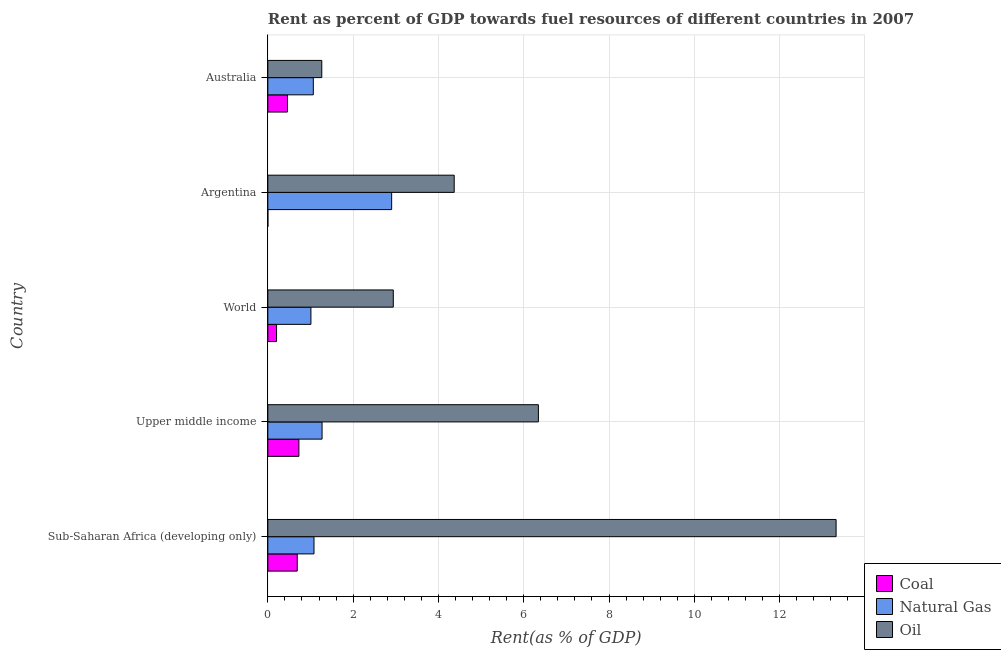How many groups of bars are there?
Your answer should be compact. 5. Are the number of bars per tick equal to the number of legend labels?
Your response must be concise. Yes. How many bars are there on the 3rd tick from the top?
Your response must be concise. 3. What is the label of the 3rd group of bars from the top?
Your response must be concise. World. What is the rent towards natural gas in Argentina?
Make the answer very short. 2.9. Across all countries, what is the maximum rent towards coal?
Offer a very short reply. 0.73. Across all countries, what is the minimum rent towards coal?
Your answer should be very brief. 0. In which country was the rent towards oil maximum?
Offer a very short reply. Sub-Saharan Africa (developing only). What is the total rent towards coal in the graph?
Your response must be concise. 2.08. What is the difference between the rent towards coal in Upper middle income and that in World?
Give a very brief answer. 0.52. What is the difference between the rent towards oil in Sub-Saharan Africa (developing only) and the rent towards coal in Upper middle income?
Make the answer very short. 12.6. What is the average rent towards natural gas per country?
Your answer should be compact. 1.47. What is the difference between the rent towards coal and rent towards oil in Upper middle income?
Offer a terse response. -5.62. In how many countries, is the rent towards oil greater than 0.4 %?
Provide a short and direct response. 5. What is the ratio of the rent towards natural gas in Argentina to that in Australia?
Provide a succinct answer. 2.72. Is the rent towards natural gas in Australia less than that in Sub-Saharan Africa (developing only)?
Your answer should be very brief. Yes. What is the difference between the highest and the second highest rent towards natural gas?
Provide a short and direct response. 1.63. What is the difference between the highest and the lowest rent towards oil?
Provide a short and direct response. 12.06. What does the 2nd bar from the top in World represents?
Keep it short and to the point. Natural Gas. What does the 2nd bar from the bottom in World represents?
Keep it short and to the point. Natural Gas. Is it the case that in every country, the sum of the rent towards coal and rent towards natural gas is greater than the rent towards oil?
Keep it short and to the point. No. How many bars are there?
Provide a short and direct response. 15. How many countries are there in the graph?
Ensure brevity in your answer.  5. Does the graph contain grids?
Provide a short and direct response. Yes. Where does the legend appear in the graph?
Your answer should be compact. Bottom right. What is the title of the graph?
Provide a short and direct response. Rent as percent of GDP towards fuel resources of different countries in 2007. Does "Travel services" appear as one of the legend labels in the graph?
Your answer should be compact. No. What is the label or title of the X-axis?
Offer a very short reply. Rent(as % of GDP). What is the Rent(as % of GDP) of Coal in Sub-Saharan Africa (developing only)?
Offer a terse response. 0.69. What is the Rent(as % of GDP) of Natural Gas in Sub-Saharan Africa (developing only)?
Give a very brief answer. 1.08. What is the Rent(as % of GDP) in Oil in Sub-Saharan Africa (developing only)?
Provide a succinct answer. 13.33. What is the Rent(as % of GDP) of Coal in Upper middle income?
Your answer should be compact. 0.73. What is the Rent(as % of GDP) of Natural Gas in Upper middle income?
Your answer should be very brief. 1.27. What is the Rent(as % of GDP) of Oil in Upper middle income?
Keep it short and to the point. 6.34. What is the Rent(as % of GDP) of Coal in World?
Your response must be concise. 0.2. What is the Rent(as % of GDP) of Natural Gas in World?
Give a very brief answer. 1.01. What is the Rent(as % of GDP) in Oil in World?
Provide a short and direct response. 2.94. What is the Rent(as % of GDP) in Coal in Argentina?
Give a very brief answer. 0. What is the Rent(as % of GDP) in Natural Gas in Argentina?
Provide a short and direct response. 2.9. What is the Rent(as % of GDP) of Oil in Argentina?
Keep it short and to the point. 4.37. What is the Rent(as % of GDP) in Coal in Australia?
Offer a terse response. 0.46. What is the Rent(as % of GDP) in Natural Gas in Australia?
Your answer should be very brief. 1.07. What is the Rent(as % of GDP) in Oil in Australia?
Make the answer very short. 1.26. Across all countries, what is the maximum Rent(as % of GDP) in Coal?
Offer a very short reply. 0.73. Across all countries, what is the maximum Rent(as % of GDP) in Natural Gas?
Your response must be concise. 2.9. Across all countries, what is the maximum Rent(as % of GDP) of Oil?
Ensure brevity in your answer.  13.33. Across all countries, what is the minimum Rent(as % of GDP) of Coal?
Provide a short and direct response. 0. Across all countries, what is the minimum Rent(as % of GDP) in Natural Gas?
Ensure brevity in your answer.  1.01. Across all countries, what is the minimum Rent(as % of GDP) in Oil?
Make the answer very short. 1.26. What is the total Rent(as % of GDP) in Coal in the graph?
Offer a very short reply. 2.08. What is the total Rent(as % of GDP) in Natural Gas in the graph?
Make the answer very short. 7.33. What is the total Rent(as % of GDP) in Oil in the graph?
Keep it short and to the point. 28.25. What is the difference between the Rent(as % of GDP) of Coal in Sub-Saharan Africa (developing only) and that in Upper middle income?
Offer a terse response. -0.04. What is the difference between the Rent(as % of GDP) in Natural Gas in Sub-Saharan Africa (developing only) and that in Upper middle income?
Keep it short and to the point. -0.19. What is the difference between the Rent(as % of GDP) in Oil in Sub-Saharan Africa (developing only) and that in Upper middle income?
Your answer should be compact. 6.98. What is the difference between the Rent(as % of GDP) in Coal in Sub-Saharan Africa (developing only) and that in World?
Keep it short and to the point. 0.48. What is the difference between the Rent(as % of GDP) in Natural Gas in Sub-Saharan Africa (developing only) and that in World?
Ensure brevity in your answer.  0.07. What is the difference between the Rent(as % of GDP) in Oil in Sub-Saharan Africa (developing only) and that in World?
Your response must be concise. 10.38. What is the difference between the Rent(as % of GDP) of Coal in Sub-Saharan Africa (developing only) and that in Argentina?
Ensure brevity in your answer.  0.69. What is the difference between the Rent(as % of GDP) in Natural Gas in Sub-Saharan Africa (developing only) and that in Argentina?
Offer a terse response. -1.82. What is the difference between the Rent(as % of GDP) of Oil in Sub-Saharan Africa (developing only) and that in Argentina?
Provide a succinct answer. 8.96. What is the difference between the Rent(as % of GDP) of Coal in Sub-Saharan Africa (developing only) and that in Australia?
Your answer should be very brief. 0.23. What is the difference between the Rent(as % of GDP) of Natural Gas in Sub-Saharan Africa (developing only) and that in Australia?
Make the answer very short. 0.02. What is the difference between the Rent(as % of GDP) in Oil in Sub-Saharan Africa (developing only) and that in Australia?
Offer a very short reply. 12.06. What is the difference between the Rent(as % of GDP) of Coal in Upper middle income and that in World?
Ensure brevity in your answer.  0.52. What is the difference between the Rent(as % of GDP) in Natural Gas in Upper middle income and that in World?
Keep it short and to the point. 0.26. What is the difference between the Rent(as % of GDP) of Oil in Upper middle income and that in World?
Provide a succinct answer. 3.4. What is the difference between the Rent(as % of GDP) of Coal in Upper middle income and that in Argentina?
Your response must be concise. 0.73. What is the difference between the Rent(as % of GDP) of Natural Gas in Upper middle income and that in Argentina?
Ensure brevity in your answer.  -1.63. What is the difference between the Rent(as % of GDP) in Oil in Upper middle income and that in Argentina?
Ensure brevity in your answer.  1.97. What is the difference between the Rent(as % of GDP) of Coal in Upper middle income and that in Australia?
Ensure brevity in your answer.  0.27. What is the difference between the Rent(as % of GDP) of Natural Gas in Upper middle income and that in Australia?
Make the answer very short. 0.21. What is the difference between the Rent(as % of GDP) of Oil in Upper middle income and that in Australia?
Make the answer very short. 5.08. What is the difference between the Rent(as % of GDP) of Coal in World and that in Argentina?
Offer a terse response. 0.2. What is the difference between the Rent(as % of GDP) in Natural Gas in World and that in Argentina?
Provide a succinct answer. -1.89. What is the difference between the Rent(as % of GDP) of Oil in World and that in Argentina?
Your answer should be very brief. -1.43. What is the difference between the Rent(as % of GDP) of Coal in World and that in Australia?
Make the answer very short. -0.26. What is the difference between the Rent(as % of GDP) in Natural Gas in World and that in Australia?
Offer a terse response. -0.06. What is the difference between the Rent(as % of GDP) of Oil in World and that in Australia?
Offer a very short reply. 1.68. What is the difference between the Rent(as % of GDP) of Coal in Argentina and that in Australia?
Offer a very short reply. -0.46. What is the difference between the Rent(as % of GDP) of Natural Gas in Argentina and that in Australia?
Provide a succinct answer. 1.84. What is the difference between the Rent(as % of GDP) of Oil in Argentina and that in Australia?
Your answer should be very brief. 3.11. What is the difference between the Rent(as % of GDP) in Coal in Sub-Saharan Africa (developing only) and the Rent(as % of GDP) in Natural Gas in Upper middle income?
Provide a succinct answer. -0.58. What is the difference between the Rent(as % of GDP) of Coal in Sub-Saharan Africa (developing only) and the Rent(as % of GDP) of Oil in Upper middle income?
Your answer should be very brief. -5.66. What is the difference between the Rent(as % of GDP) in Natural Gas in Sub-Saharan Africa (developing only) and the Rent(as % of GDP) in Oil in Upper middle income?
Your response must be concise. -5.26. What is the difference between the Rent(as % of GDP) in Coal in Sub-Saharan Africa (developing only) and the Rent(as % of GDP) in Natural Gas in World?
Offer a terse response. -0.32. What is the difference between the Rent(as % of GDP) of Coal in Sub-Saharan Africa (developing only) and the Rent(as % of GDP) of Oil in World?
Ensure brevity in your answer.  -2.25. What is the difference between the Rent(as % of GDP) in Natural Gas in Sub-Saharan Africa (developing only) and the Rent(as % of GDP) in Oil in World?
Give a very brief answer. -1.86. What is the difference between the Rent(as % of GDP) in Coal in Sub-Saharan Africa (developing only) and the Rent(as % of GDP) in Natural Gas in Argentina?
Your response must be concise. -2.21. What is the difference between the Rent(as % of GDP) in Coal in Sub-Saharan Africa (developing only) and the Rent(as % of GDP) in Oil in Argentina?
Give a very brief answer. -3.68. What is the difference between the Rent(as % of GDP) in Natural Gas in Sub-Saharan Africa (developing only) and the Rent(as % of GDP) in Oil in Argentina?
Your response must be concise. -3.29. What is the difference between the Rent(as % of GDP) of Coal in Sub-Saharan Africa (developing only) and the Rent(as % of GDP) of Natural Gas in Australia?
Give a very brief answer. -0.38. What is the difference between the Rent(as % of GDP) of Coal in Sub-Saharan Africa (developing only) and the Rent(as % of GDP) of Oil in Australia?
Ensure brevity in your answer.  -0.58. What is the difference between the Rent(as % of GDP) in Natural Gas in Sub-Saharan Africa (developing only) and the Rent(as % of GDP) in Oil in Australia?
Provide a succinct answer. -0.18. What is the difference between the Rent(as % of GDP) in Coal in Upper middle income and the Rent(as % of GDP) in Natural Gas in World?
Your response must be concise. -0.28. What is the difference between the Rent(as % of GDP) in Coal in Upper middle income and the Rent(as % of GDP) in Oil in World?
Keep it short and to the point. -2.21. What is the difference between the Rent(as % of GDP) of Natural Gas in Upper middle income and the Rent(as % of GDP) of Oil in World?
Your answer should be very brief. -1.67. What is the difference between the Rent(as % of GDP) in Coal in Upper middle income and the Rent(as % of GDP) in Natural Gas in Argentina?
Keep it short and to the point. -2.17. What is the difference between the Rent(as % of GDP) in Coal in Upper middle income and the Rent(as % of GDP) in Oil in Argentina?
Your response must be concise. -3.64. What is the difference between the Rent(as % of GDP) in Natural Gas in Upper middle income and the Rent(as % of GDP) in Oil in Argentina?
Provide a succinct answer. -3.1. What is the difference between the Rent(as % of GDP) of Coal in Upper middle income and the Rent(as % of GDP) of Natural Gas in Australia?
Provide a short and direct response. -0.34. What is the difference between the Rent(as % of GDP) of Coal in Upper middle income and the Rent(as % of GDP) of Oil in Australia?
Your answer should be very brief. -0.54. What is the difference between the Rent(as % of GDP) of Natural Gas in Upper middle income and the Rent(as % of GDP) of Oil in Australia?
Keep it short and to the point. 0.01. What is the difference between the Rent(as % of GDP) of Coal in World and the Rent(as % of GDP) of Natural Gas in Argentina?
Keep it short and to the point. -2.7. What is the difference between the Rent(as % of GDP) of Coal in World and the Rent(as % of GDP) of Oil in Argentina?
Offer a very short reply. -4.17. What is the difference between the Rent(as % of GDP) of Natural Gas in World and the Rent(as % of GDP) of Oil in Argentina?
Provide a short and direct response. -3.36. What is the difference between the Rent(as % of GDP) in Coal in World and the Rent(as % of GDP) in Natural Gas in Australia?
Ensure brevity in your answer.  -0.86. What is the difference between the Rent(as % of GDP) in Coal in World and the Rent(as % of GDP) in Oil in Australia?
Give a very brief answer. -1.06. What is the difference between the Rent(as % of GDP) of Natural Gas in World and the Rent(as % of GDP) of Oil in Australia?
Offer a very short reply. -0.25. What is the difference between the Rent(as % of GDP) of Coal in Argentina and the Rent(as % of GDP) of Natural Gas in Australia?
Provide a short and direct response. -1.07. What is the difference between the Rent(as % of GDP) in Coal in Argentina and the Rent(as % of GDP) in Oil in Australia?
Provide a short and direct response. -1.26. What is the difference between the Rent(as % of GDP) of Natural Gas in Argentina and the Rent(as % of GDP) of Oil in Australia?
Make the answer very short. 1.64. What is the average Rent(as % of GDP) of Coal per country?
Provide a succinct answer. 0.42. What is the average Rent(as % of GDP) in Natural Gas per country?
Provide a short and direct response. 1.47. What is the average Rent(as % of GDP) of Oil per country?
Provide a succinct answer. 5.65. What is the difference between the Rent(as % of GDP) of Coal and Rent(as % of GDP) of Natural Gas in Sub-Saharan Africa (developing only)?
Provide a succinct answer. -0.39. What is the difference between the Rent(as % of GDP) in Coal and Rent(as % of GDP) in Oil in Sub-Saharan Africa (developing only)?
Make the answer very short. -12.64. What is the difference between the Rent(as % of GDP) in Natural Gas and Rent(as % of GDP) in Oil in Sub-Saharan Africa (developing only)?
Your response must be concise. -12.24. What is the difference between the Rent(as % of GDP) in Coal and Rent(as % of GDP) in Natural Gas in Upper middle income?
Your answer should be very brief. -0.54. What is the difference between the Rent(as % of GDP) of Coal and Rent(as % of GDP) of Oil in Upper middle income?
Ensure brevity in your answer.  -5.62. What is the difference between the Rent(as % of GDP) in Natural Gas and Rent(as % of GDP) in Oil in Upper middle income?
Your response must be concise. -5.07. What is the difference between the Rent(as % of GDP) in Coal and Rent(as % of GDP) in Natural Gas in World?
Offer a terse response. -0.81. What is the difference between the Rent(as % of GDP) of Coal and Rent(as % of GDP) of Oil in World?
Provide a short and direct response. -2.74. What is the difference between the Rent(as % of GDP) of Natural Gas and Rent(as % of GDP) of Oil in World?
Offer a very short reply. -1.93. What is the difference between the Rent(as % of GDP) of Coal and Rent(as % of GDP) of Natural Gas in Argentina?
Provide a short and direct response. -2.9. What is the difference between the Rent(as % of GDP) of Coal and Rent(as % of GDP) of Oil in Argentina?
Offer a terse response. -4.37. What is the difference between the Rent(as % of GDP) of Natural Gas and Rent(as % of GDP) of Oil in Argentina?
Provide a succinct answer. -1.47. What is the difference between the Rent(as % of GDP) in Coal and Rent(as % of GDP) in Natural Gas in Australia?
Make the answer very short. -0.61. What is the difference between the Rent(as % of GDP) of Coal and Rent(as % of GDP) of Oil in Australia?
Your response must be concise. -0.81. What is the difference between the Rent(as % of GDP) in Natural Gas and Rent(as % of GDP) in Oil in Australia?
Your answer should be very brief. -0.2. What is the ratio of the Rent(as % of GDP) of Coal in Sub-Saharan Africa (developing only) to that in Upper middle income?
Provide a short and direct response. 0.95. What is the ratio of the Rent(as % of GDP) in Natural Gas in Sub-Saharan Africa (developing only) to that in Upper middle income?
Give a very brief answer. 0.85. What is the ratio of the Rent(as % of GDP) in Oil in Sub-Saharan Africa (developing only) to that in Upper middle income?
Provide a short and direct response. 2.1. What is the ratio of the Rent(as % of GDP) in Coal in Sub-Saharan Africa (developing only) to that in World?
Offer a terse response. 3.37. What is the ratio of the Rent(as % of GDP) of Natural Gas in Sub-Saharan Africa (developing only) to that in World?
Keep it short and to the point. 1.07. What is the ratio of the Rent(as % of GDP) of Oil in Sub-Saharan Africa (developing only) to that in World?
Keep it short and to the point. 4.53. What is the ratio of the Rent(as % of GDP) in Coal in Sub-Saharan Africa (developing only) to that in Argentina?
Your answer should be compact. 1523.21. What is the ratio of the Rent(as % of GDP) in Natural Gas in Sub-Saharan Africa (developing only) to that in Argentina?
Offer a very short reply. 0.37. What is the ratio of the Rent(as % of GDP) of Oil in Sub-Saharan Africa (developing only) to that in Argentina?
Provide a succinct answer. 3.05. What is the ratio of the Rent(as % of GDP) of Coal in Sub-Saharan Africa (developing only) to that in Australia?
Provide a succinct answer. 1.5. What is the ratio of the Rent(as % of GDP) in Natural Gas in Sub-Saharan Africa (developing only) to that in Australia?
Your answer should be very brief. 1.01. What is the ratio of the Rent(as % of GDP) in Oil in Sub-Saharan Africa (developing only) to that in Australia?
Ensure brevity in your answer.  10.54. What is the ratio of the Rent(as % of GDP) of Coal in Upper middle income to that in World?
Your response must be concise. 3.56. What is the ratio of the Rent(as % of GDP) of Natural Gas in Upper middle income to that in World?
Ensure brevity in your answer.  1.26. What is the ratio of the Rent(as % of GDP) in Oil in Upper middle income to that in World?
Provide a short and direct response. 2.16. What is the ratio of the Rent(as % of GDP) in Coal in Upper middle income to that in Argentina?
Your answer should be compact. 1610.21. What is the ratio of the Rent(as % of GDP) in Natural Gas in Upper middle income to that in Argentina?
Your answer should be very brief. 0.44. What is the ratio of the Rent(as % of GDP) of Oil in Upper middle income to that in Argentina?
Provide a succinct answer. 1.45. What is the ratio of the Rent(as % of GDP) in Coal in Upper middle income to that in Australia?
Provide a succinct answer. 1.58. What is the ratio of the Rent(as % of GDP) of Natural Gas in Upper middle income to that in Australia?
Your answer should be very brief. 1.19. What is the ratio of the Rent(as % of GDP) in Oil in Upper middle income to that in Australia?
Give a very brief answer. 5.02. What is the ratio of the Rent(as % of GDP) in Coal in World to that in Argentina?
Your answer should be very brief. 451.77. What is the ratio of the Rent(as % of GDP) in Natural Gas in World to that in Argentina?
Your answer should be very brief. 0.35. What is the ratio of the Rent(as % of GDP) of Oil in World to that in Argentina?
Provide a succinct answer. 0.67. What is the ratio of the Rent(as % of GDP) of Coal in World to that in Australia?
Give a very brief answer. 0.44. What is the ratio of the Rent(as % of GDP) of Natural Gas in World to that in Australia?
Provide a succinct answer. 0.95. What is the ratio of the Rent(as % of GDP) in Oil in World to that in Australia?
Ensure brevity in your answer.  2.33. What is the ratio of the Rent(as % of GDP) of Coal in Argentina to that in Australia?
Your answer should be very brief. 0. What is the ratio of the Rent(as % of GDP) in Natural Gas in Argentina to that in Australia?
Make the answer very short. 2.72. What is the ratio of the Rent(as % of GDP) in Oil in Argentina to that in Australia?
Your response must be concise. 3.45. What is the difference between the highest and the second highest Rent(as % of GDP) in Coal?
Your answer should be very brief. 0.04. What is the difference between the highest and the second highest Rent(as % of GDP) in Natural Gas?
Provide a succinct answer. 1.63. What is the difference between the highest and the second highest Rent(as % of GDP) of Oil?
Give a very brief answer. 6.98. What is the difference between the highest and the lowest Rent(as % of GDP) in Coal?
Your answer should be compact. 0.73. What is the difference between the highest and the lowest Rent(as % of GDP) in Natural Gas?
Your answer should be compact. 1.89. What is the difference between the highest and the lowest Rent(as % of GDP) in Oil?
Ensure brevity in your answer.  12.06. 